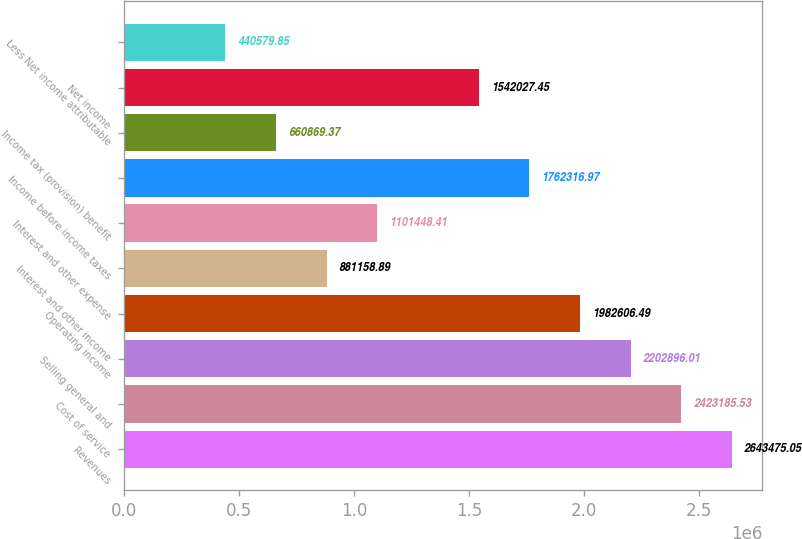Convert chart to OTSL. <chart><loc_0><loc_0><loc_500><loc_500><bar_chart><fcel>Revenues<fcel>Cost of service<fcel>Selling general and<fcel>Operating income<fcel>Interest and other income<fcel>Interest and other expense<fcel>Income before income taxes<fcel>Income tax (provision) benefit<fcel>Net income<fcel>Less Net income attributable<nl><fcel>2.64348e+06<fcel>2.42319e+06<fcel>2.2029e+06<fcel>1.98261e+06<fcel>881159<fcel>1.10145e+06<fcel>1.76232e+06<fcel>660869<fcel>1.54203e+06<fcel>440580<nl></chart> 